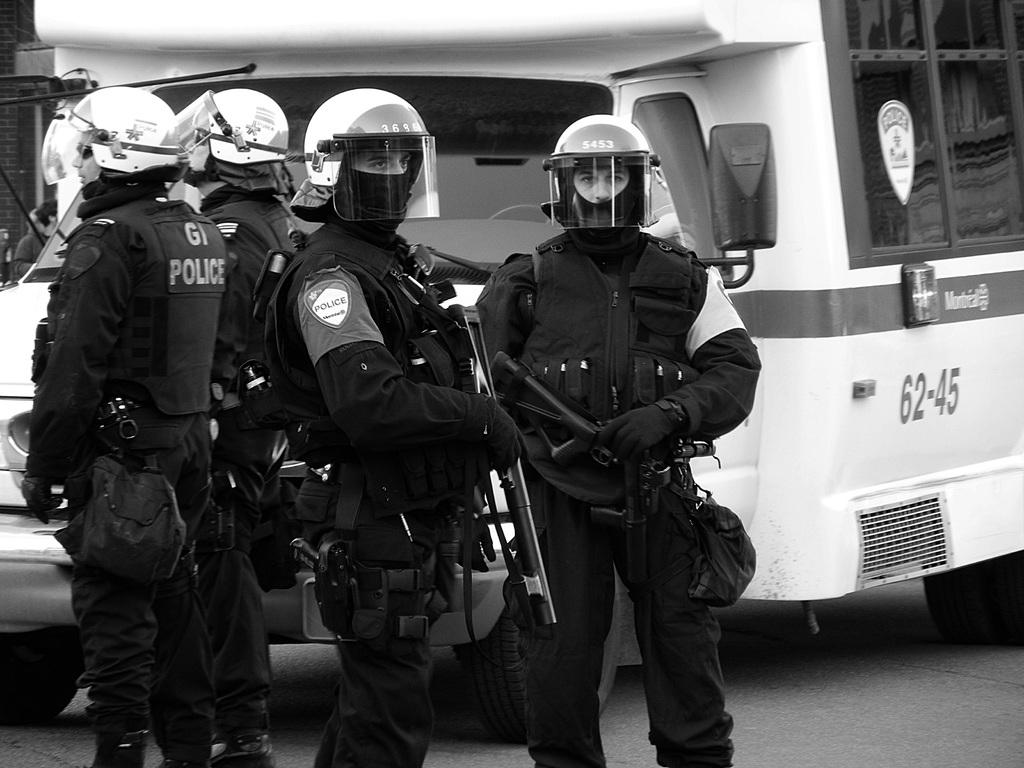What are the main subjects in the image? There are police persons standing in the center of the image. Can you describe the setting or background of the image? There is a van in the background of the image. What type of yarn is being used by the police persons in the image? There is no yarn present in the image; the police persons are not using any yarn. 